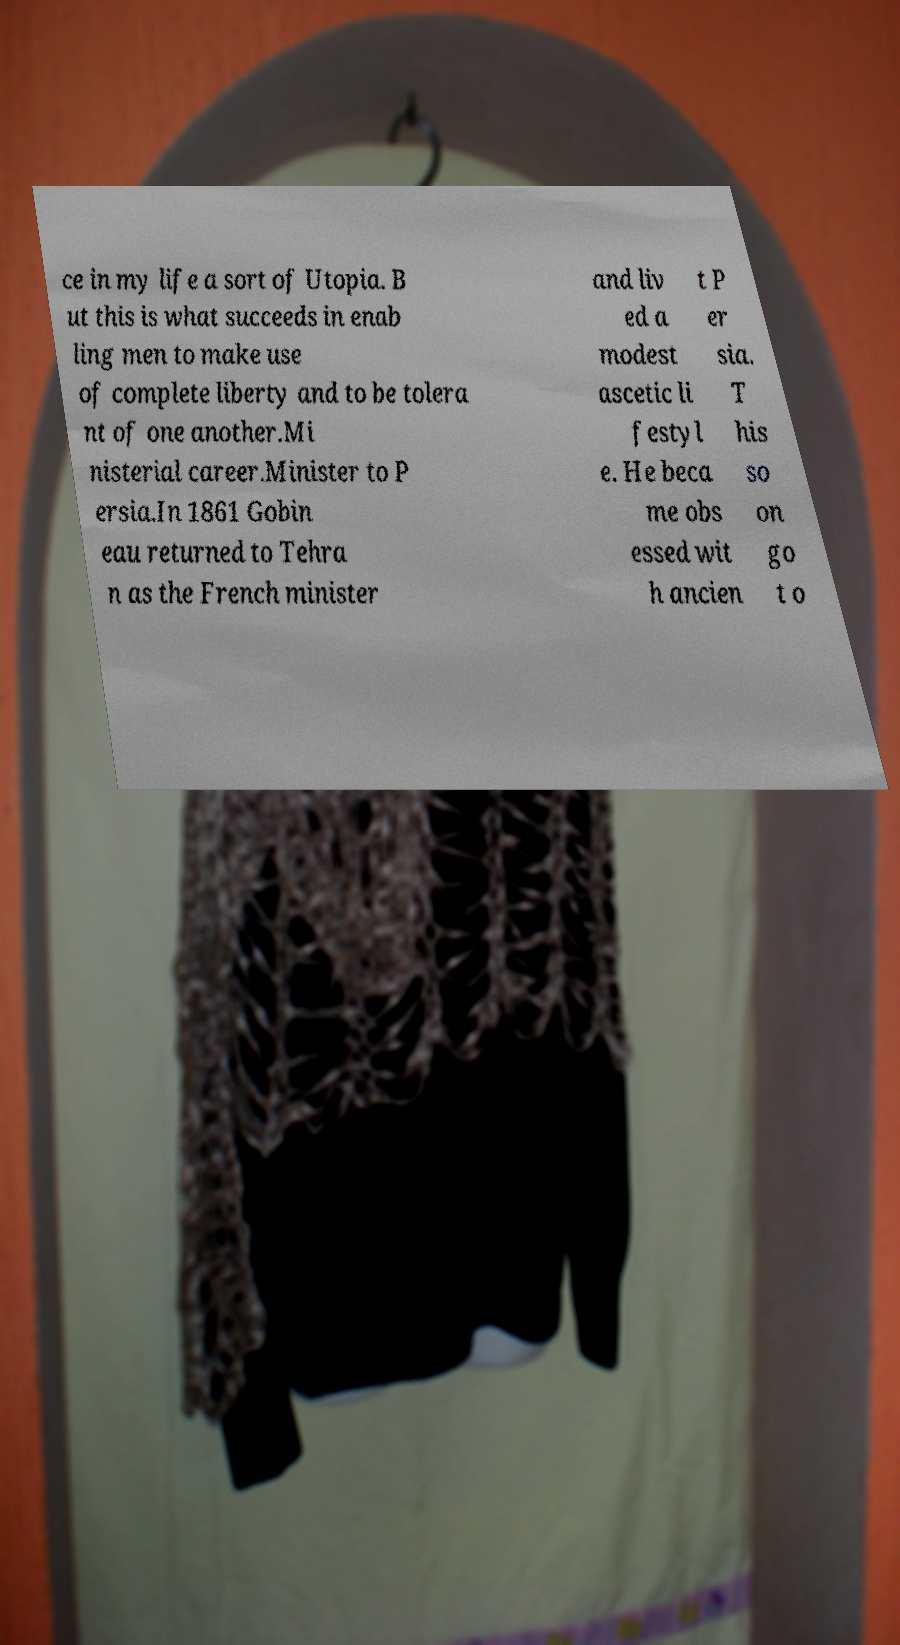Can you accurately transcribe the text from the provided image for me? ce in my life a sort of Utopia. B ut this is what succeeds in enab ling men to make use of complete liberty and to be tolera nt of one another.Mi nisterial career.Minister to P ersia.In 1861 Gobin eau returned to Tehra n as the French minister and liv ed a modest ascetic li festyl e. He beca me obs essed wit h ancien t P er sia. T his so on go t o 